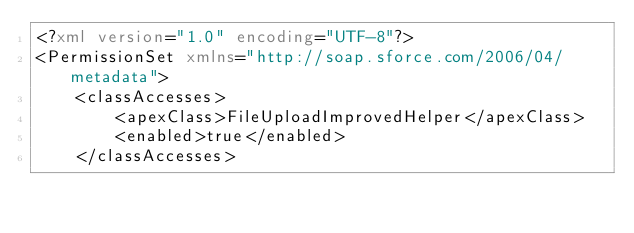Convert code to text. <code><loc_0><loc_0><loc_500><loc_500><_XML_><?xml version="1.0" encoding="UTF-8"?>
<PermissionSet xmlns="http://soap.sforce.com/2006/04/metadata">
    <classAccesses>
        <apexClass>FileUploadImprovedHelper</apexClass>
        <enabled>true</enabled>
    </classAccesses></code> 